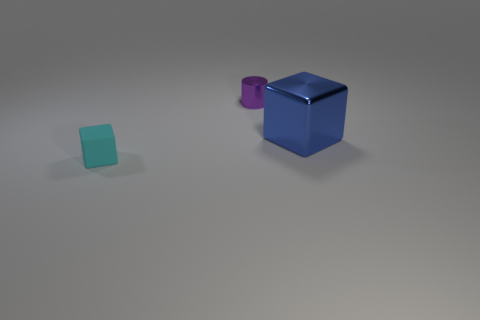Add 2 tiny gray rubber objects. How many objects exist? 5 Subtract all cylinders. How many objects are left? 2 Subtract all big blue metallic blocks. Subtract all purple metallic things. How many objects are left? 1 Add 2 shiny things. How many shiny things are left? 4 Add 3 green rubber cubes. How many green rubber cubes exist? 3 Subtract 0 purple cubes. How many objects are left? 3 